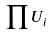<formula> <loc_0><loc_0><loc_500><loc_500>\prod U _ { i }</formula> 